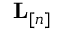Convert formula to latex. <formula><loc_0><loc_0><loc_500><loc_500>{ L } _ { [ n ] }</formula> 